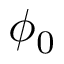Convert formula to latex. <formula><loc_0><loc_0><loc_500><loc_500>\phi _ { 0 }</formula> 